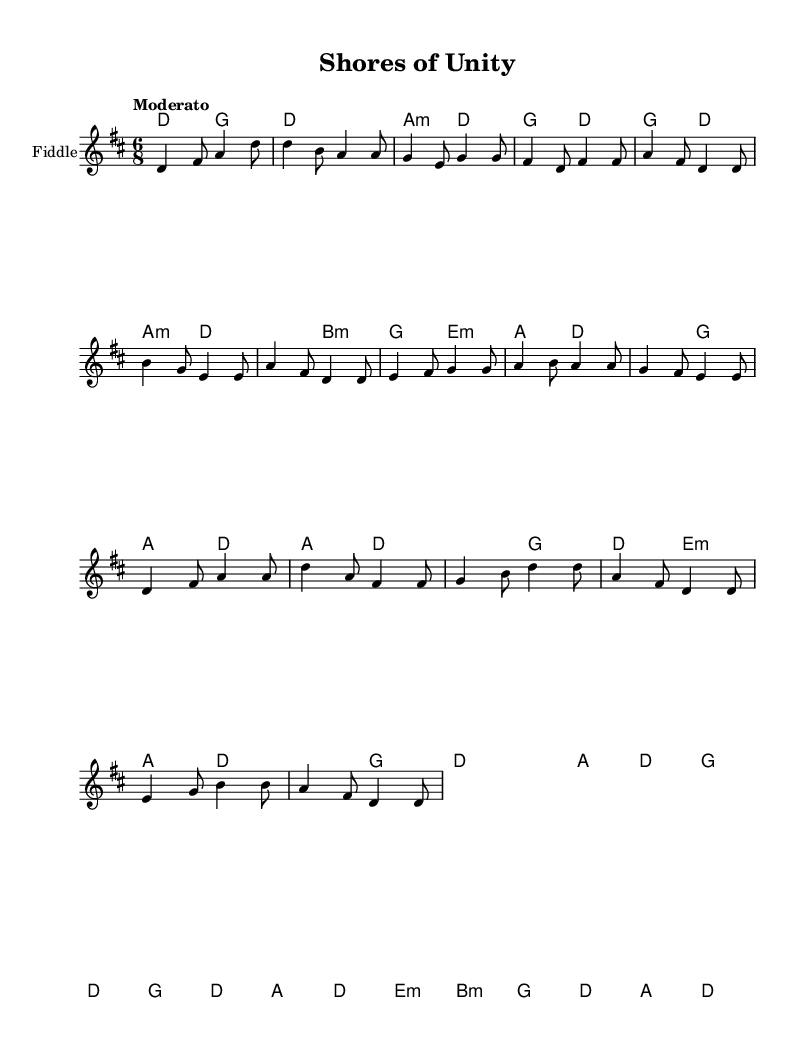What is the key signature of this music? The key signature indicates there are two sharps (F# and C#) visible in the music notation, which corresponds to D major.
Answer: D major What is the time signature of this music? Reading the notation, the time signature is 6/8, which is specified at the beginning and shows that there are six eighth notes per measure.
Answer: 6/8 What is the tempo marking of this music? The tempo marking “Moderato” is indicated above the staff, suggesting a moderate speed for the piece.
Answer: Moderato How many measures are there in total? By counting the individual measures in the melody section, we find that there are sixteen distinct measures present in the music sheet.
Answer: 16 What type of scale does this tune primarily use? Observing the notes in the melody, the tune predominantly uses a mix of steps and leaps typical of a major scale, suggesting it is based on D major.
Answer: Major scale What is the name of the piece? The title "Shores of Unity" is given at the top header of the sheet music, identifying this specific composition.
Answer: Shores of Unity What is the primary instrument indicated for playing this piece? The notation specifies "Fiddle" as the instrument name, indicating that this music is arranged for that specific instrument.
Answer: Fiddle 